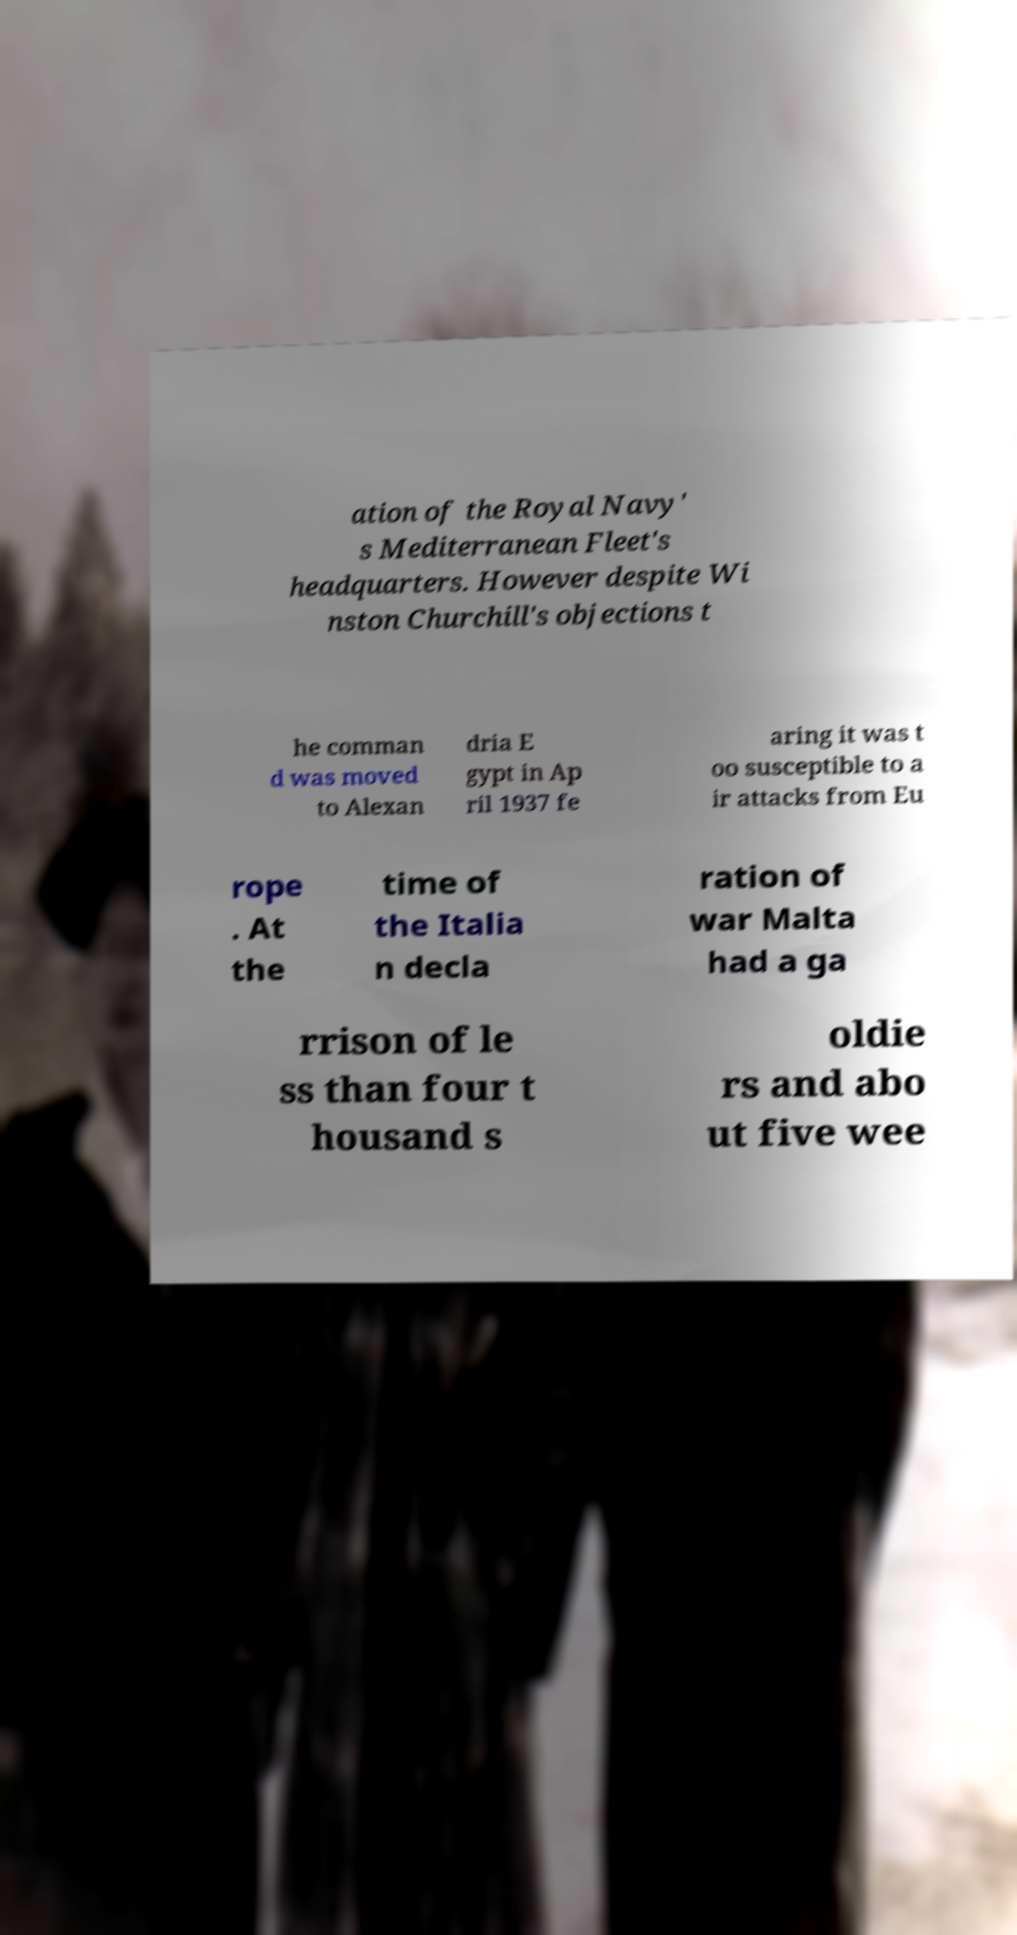Could you extract and type out the text from this image? ation of the Royal Navy' s Mediterranean Fleet's headquarters. However despite Wi nston Churchill's objections t he comman d was moved to Alexan dria E gypt in Ap ril 1937 fe aring it was t oo susceptible to a ir attacks from Eu rope . At the time of the Italia n decla ration of war Malta had a ga rrison of le ss than four t housand s oldie rs and abo ut five wee 